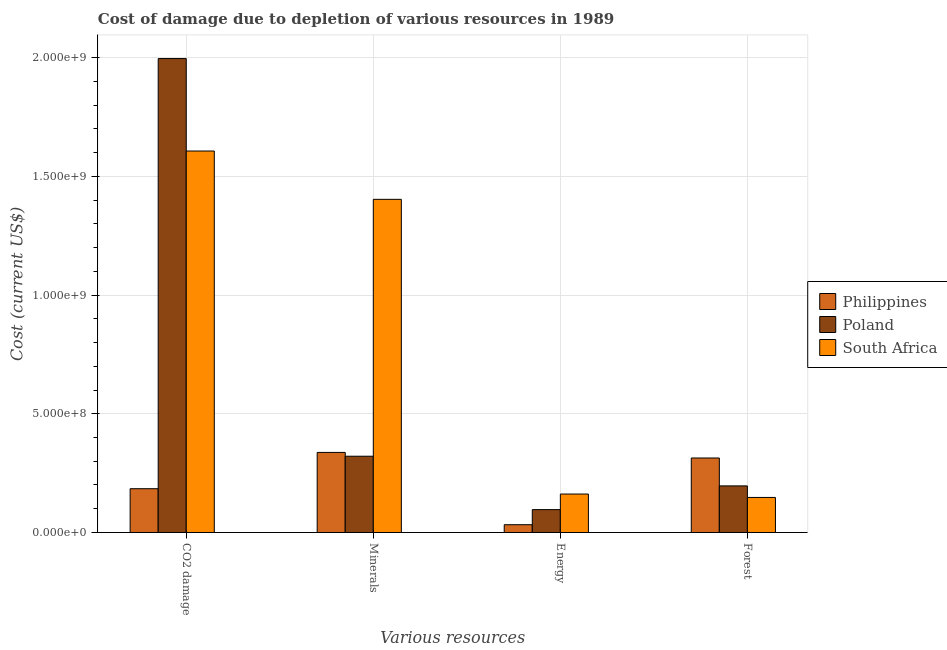How many groups of bars are there?
Your response must be concise. 4. Are the number of bars per tick equal to the number of legend labels?
Keep it short and to the point. Yes. Are the number of bars on each tick of the X-axis equal?
Provide a succinct answer. Yes. How many bars are there on the 3rd tick from the right?
Ensure brevity in your answer.  3. What is the label of the 3rd group of bars from the left?
Provide a succinct answer. Energy. What is the cost of damage due to depletion of energy in Philippines?
Your response must be concise. 3.27e+07. Across all countries, what is the maximum cost of damage due to depletion of coal?
Your answer should be compact. 2.00e+09. Across all countries, what is the minimum cost of damage due to depletion of coal?
Offer a terse response. 1.84e+08. In which country was the cost of damage due to depletion of minerals minimum?
Offer a terse response. Poland. What is the total cost of damage due to depletion of energy in the graph?
Ensure brevity in your answer.  2.91e+08. What is the difference between the cost of damage due to depletion of forests in South Africa and that in Poland?
Your answer should be very brief. -4.87e+07. What is the difference between the cost of damage due to depletion of coal in Poland and the cost of damage due to depletion of energy in South Africa?
Your answer should be very brief. 1.83e+09. What is the average cost of damage due to depletion of energy per country?
Ensure brevity in your answer.  9.70e+07. What is the difference between the cost of damage due to depletion of forests and cost of damage due to depletion of energy in Poland?
Provide a succinct answer. 9.99e+07. In how many countries, is the cost of damage due to depletion of minerals greater than 1700000000 US$?
Provide a succinct answer. 0. What is the ratio of the cost of damage due to depletion of forests in South Africa to that in Philippines?
Keep it short and to the point. 0.47. What is the difference between the highest and the second highest cost of damage due to depletion of energy?
Provide a succinct answer. 6.56e+07. What is the difference between the highest and the lowest cost of damage due to depletion of minerals?
Keep it short and to the point. 1.08e+09. What does the 1st bar from the left in CO2 damage represents?
Offer a very short reply. Philippines. What does the 3rd bar from the right in CO2 damage represents?
Keep it short and to the point. Philippines. Is it the case that in every country, the sum of the cost of damage due to depletion of coal and cost of damage due to depletion of minerals is greater than the cost of damage due to depletion of energy?
Your answer should be very brief. Yes. Are all the bars in the graph horizontal?
Provide a short and direct response. No. How many countries are there in the graph?
Ensure brevity in your answer.  3. Are the values on the major ticks of Y-axis written in scientific E-notation?
Offer a very short reply. Yes. How are the legend labels stacked?
Make the answer very short. Vertical. What is the title of the graph?
Provide a short and direct response. Cost of damage due to depletion of various resources in 1989 . Does "Thailand" appear as one of the legend labels in the graph?
Your answer should be compact. No. What is the label or title of the X-axis?
Your answer should be very brief. Various resources. What is the label or title of the Y-axis?
Keep it short and to the point. Cost (current US$). What is the Cost (current US$) in Philippines in CO2 damage?
Give a very brief answer. 1.84e+08. What is the Cost (current US$) in Poland in CO2 damage?
Provide a short and direct response. 2.00e+09. What is the Cost (current US$) of South Africa in CO2 damage?
Provide a succinct answer. 1.61e+09. What is the Cost (current US$) of Philippines in Minerals?
Offer a terse response. 3.37e+08. What is the Cost (current US$) in Poland in Minerals?
Your answer should be very brief. 3.21e+08. What is the Cost (current US$) in South Africa in Minerals?
Keep it short and to the point. 1.40e+09. What is the Cost (current US$) in Philippines in Energy?
Provide a succinct answer. 3.27e+07. What is the Cost (current US$) of Poland in Energy?
Your answer should be compact. 9.63e+07. What is the Cost (current US$) in South Africa in Energy?
Give a very brief answer. 1.62e+08. What is the Cost (current US$) of Philippines in Forest?
Your answer should be compact. 3.14e+08. What is the Cost (current US$) in Poland in Forest?
Provide a short and direct response. 1.96e+08. What is the Cost (current US$) in South Africa in Forest?
Offer a terse response. 1.48e+08. Across all Various resources, what is the maximum Cost (current US$) of Philippines?
Offer a terse response. 3.37e+08. Across all Various resources, what is the maximum Cost (current US$) of Poland?
Your answer should be very brief. 2.00e+09. Across all Various resources, what is the maximum Cost (current US$) in South Africa?
Provide a short and direct response. 1.61e+09. Across all Various resources, what is the minimum Cost (current US$) in Philippines?
Provide a succinct answer. 3.27e+07. Across all Various resources, what is the minimum Cost (current US$) of Poland?
Offer a very short reply. 9.63e+07. Across all Various resources, what is the minimum Cost (current US$) of South Africa?
Offer a very short reply. 1.48e+08. What is the total Cost (current US$) of Philippines in the graph?
Provide a short and direct response. 8.68e+08. What is the total Cost (current US$) of Poland in the graph?
Provide a short and direct response. 2.61e+09. What is the total Cost (current US$) of South Africa in the graph?
Offer a terse response. 3.32e+09. What is the difference between the Cost (current US$) of Philippines in CO2 damage and that in Minerals?
Keep it short and to the point. -1.53e+08. What is the difference between the Cost (current US$) of Poland in CO2 damage and that in Minerals?
Your answer should be very brief. 1.67e+09. What is the difference between the Cost (current US$) in South Africa in CO2 damage and that in Minerals?
Ensure brevity in your answer.  2.03e+08. What is the difference between the Cost (current US$) in Philippines in CO2 damage and that in Energy?
Provide a short and direct response. 1.52e+08. What is the difference between the Cost (current US$) in Poland in CO2 damage and that in Energy?
Offer a terse response. 1.90e+09. What is the difference between the Cost (current US$) of South Africa in CO2 damage and that in Energy?
Your response must be concise. 1.44e+09. What is the difference between the Cost (current US$) in Philippines in CO2 damage and that in Forest?
Provide a succinct answer. -1.29e+08. What is the difference between the Cost (current US$) of Poland in CO2 damage and that in Forest?
Provide a short and direct response. 1.80e+09. What is the difference between the Cost (current US$) in South Africa in CO2 damage and that in Forest?
Keep it short and to the point. 1.46e+09. What is the difference between the Cost (current US$) in Philippines in Minerals and that in Energy?
Make the answer very short. 3.04e+08. What is the difference between the Cost (current US$) in Poland in Minerals and that in Energy?
Provide a succinct answer. 2.25e+08. What is the difference between the Cost (current US$) in South Africa in Minerals and that in Energy?
Give a very brief answer. 1.24e+09. What is the difference between the Cost (current US$) in Philippines in Minerals and that in Forest?
Give a very brief answer. 2.35e+07. What is the difference between the Cost (current US$) of Poland in Minerals and that in Forest?
Your answer should be compact. 1.25e+08. What is the difference between the Cost (current US$) in South Africa in Minerals and that in Forest?
Provide a short and direct response. 1.26e+09. What is the difference between the Cost (current US$) of Philippines in Energy and that in Forest?
Provide a succinct answer. -2.81e+08. What is the difference between the Cost (current US$) of Poland in Energy and that in Forest?
Your answer should be very brief. -9.99e+07. What is the difference between the Cost (current US$) in South Africa in Energy and that in Forest?
Provide a succinct answer. 1.43e+07. What is the difference between the Cost (current US$) in Philippines in CO2 damage and the Cost (current US$) in Poland in Minerals?
Your response must be concise. -1.37e+08. What is the difference between the Cost (current US$) of Philippines in CO2 damage and the Cost (current US$) of South Africa in Minerals?
Provide a short and direct response. -1.22e+09. What is the difference between the Cost (current US$) in Poland in CO2 damage and the Cost (current US$) in South Africa in Minerals?
Your answer should be compact. 5.93e+08. What is the difference between the Cost (current US$) in Philippines in CO2 damage and the Cost (current US$) in Poland in Energy?
Your answer should be compact. 8.80e+07. What is the difference between the Cost (current US$) in Philippines in CO2 damage and the Cost (current US$) in South Africa in Energy?
Provide a succinct answer. 2.24e+07. What is the difference between the Cost (current US$) in Poland in CO2 damage and the Cost (current US$) in South Africa in Energy?
Make the answer very short. 1.83e+09. What is the difference between the Cost (current US$) in Philippines in CO2 damage and the Cost (current US$) in Poland in Forest?
Give a very brief answer. -1.19e+07. What is the difference between the Cost (current US$) in Philippines in CO2 damage and the Cost (current US$) in South Africa in Forest?
Provide a succinct answer. 3.68e+07. What is the difference between the Cost (current US$) of Poland in CO2 damage and the Cost (current US$) of South Africa in Forest?
Your answer should be compact. 1.85e+09. What is the difference between the Cost (current US$) in Philippines in Minerals and the Cost (current US$) in Poland in Energy?
Your response must be concise. 2.41e+08. What is the difference between the Cost (current US$) of Philippines in Minerals and the Cost (current US$) of South Africa in Energy?
Offer a terse response. 1.75e+08. What is the difference between the Cost (current US$) of Poland in Minerals and the Cost (current US$) of South Africa in Energy?
Offer a terse response. 1.59e+08. What is the difference between the Cost (current US$) of Philippines in Minerals and the Cost (current US$) of Poland in Forest?
Give a very brief answer. 1.41e+08. What is the difference between the Cost (current US$) of Philippines in Minerals and the Cost (current US$) of South Africa in Forest?
Make the answer very short. 1.90e+08. What is the difference between the Cost (current US$) of Poland in Minerals and the Cost (current US$) of South Africa in Forest?
Give a very brief answer. 1.74e+08. What is the difference between the Cost (current US$) in Philippines in Energy and the Cost (current US$) in Poland in Forest?
Your answer should be very brief. -1.64e+08. What is the difference between the Cost (current US$) of Philippines in Energy and the Cost (current US$) of South Africa in Forest?
Ensure brevity in your answer.  -1.15e+08. What is the difference between the Cost (current US$) in Poland in Energy and the Cost (current US$) in South Africa in Forest?
Provide a succinct answer. -5.12e+07. What is the average Cost (current US$) in Philippines per Various resources?
Make the answer very short. 2.17e+08. What is the average Cost (current US$) of Poland per Various resources?
Offer a very short reply. 6.52e+08. What is the average Cost (current US$) of South Africa per Various resources?
Your answer should be compact. 8.30e+08. What is the difference between the Cost (current US$) of Philippines and Cost (current US$) of Poland in CO2 damage?
Provide a short and direct response. -1.81e+09. What is the difference between the Cost (current US$) in Philippines and Cost (current US$) in South Africa in CO2 damage?
Your response must be concise. -1.42e+09. What is the difference between the Cost (current US$) of Poland and Cost (current US$) of South Africa in CO2 damage?
Make the answer very short. 3.89e+08. What is the difference between the Cost (current US$) in Philippines and Cost (current US$) in Poland in Minerals?
Make the answer very short. 1.60e+07. What is the difference between the Cost (current US$) in Philippines and Cost (current US$) in South Africa in Minerals?
Your response must be concise. -1.07e+09. What is the difference between the Cost (current US$) of Poland and Cost (current US$) of South Africa in Minerals?
Ensure brevity in your answer.  -1.08e+09. What is the difference between the Cost (current US$) of Philippines and Cost (current US$) of Poland in Energy?
Provide a succinct answer. -6.36e+07. What is the difference between the Cost (current US$) of Philippines and Cost (current US$) of South Africa in Energy?
Provide a short and direct response. -1.29e+08. What is the difference between the Cost (current US$) in Poland and Cost (current US$) in South Africa in Energy?
Make the answer very short. -6.56e+07. What is the difference between the Cost (current US$) in Philippines and Cost (current US$) in Poland in Forest?
Provide a succinct answer. 1.18e+08. What is the difference between the Cost (current US$) in Philippines and Cost (current US$) in South Africa in Forest?
Offer a very short reply. 1.66e+08. What is the difference between the Cost (current US$) of Poland and Cost (current US$) of South Africa in Forest?
Your answer should be compact. 4.87e+07. What is the ratio of the Cost (current US$) of Philippines in CO2 damage to that in Minerals?
Your answer should be compact. 0.55. What is the ratio of the Cost (current US$) in Poland in CO2 damage to that in Minerals?
Provide a succinct answer. 6.21. What is the ratio of the Cost (current US$) in South Africa in CO2 damage to that in Minerals?
Your answer should be compact. 1.15. What is the ratio of the Cost (current US$) of Philippines in CO2 damage to that in Energy?
Provide a short and direct response. 5.63. What is the ratio of the Cost (current US$) of Poland in CO2 damage to that in Energy?
Offer a terse response. 20.72. What is the ratio of the Cost (current US$) of South Africa in CO2 damage to that in Energy?
Ensure brevity in your answer.  9.92. What is the ratio of the Cost (current US$) in Philippines in CO2 damage to that in Forest?
Keep it short and to the point. 0.59. What is the ratio of the Cost (current US$) of Poland in CO2 damage to that in Forest?
Your answer should be compact. 10.17. What is the ratio of the Cost (current US$) of South Africa in CO2 damage to that in Forest?
Give a very brief answer. 10.89. What is the ratio of the Cost (current US$) of Philippines in Minerals to that in Energy?
Your response must be concise. 10.31. What is the ratio of the Cost (current US$) of Poland in Minerals to that in Energy?
Provide a succinct answer. 3.33. What is the ratio of the Cost (current US$) in South Africa in Minerals to that in Energy?
Your answer should be very brief. 8.67. What is the ratio of the Cost (current US$) of Philippines in Minerals to that in Forest?
Your response must be concise. 1.07. What is the ratio of the Cost (current US$) of Poland in Minerals to that in Forest?
Your response must be concise. 1.64. What is the ratio of the Cost (current US$) in South Africa in Minerals to that in Forest?
Your response must be concise. 9.51. What is the ratio of the Cost (current US$) of Philippines in Energy to that in Forest?
Ensure brevity in your answer.  0.1. What is the ratio of the Cost (current US$) of Poland in Energy to that in Forest?
Give a very brief answer. 0.49. What is the ratio of the Cost (current US$) in South Africa in Energy to that in Forest?
Your answer should be compact. 1.1. What is the difference between the highest and the second highest Cost (current US$) of Philippines?
Your response must be concise. 2.35e+07. What is the difference between the highest and the second highest Cost (current US$) in Poland?
Provide a short and direct response. 1.67e+09. What is the difference between the highest and the second highest Cost (current US$) in South Africa?
Ensure brevity in your answer.  2.03e+08. What is the difference between the highest and the lowest Cost (current US$) in Philippines?
Provide a short and direct response. 3.04e+08. What is the difference between the highest and the lowest Cost (current US$) in Poland?
Offer a very short reply. 1.90e+09. What is the difference between the highest and the lowest Cost (current US$) of South Africa?
Give a very brief answer. 1.46e+09. 